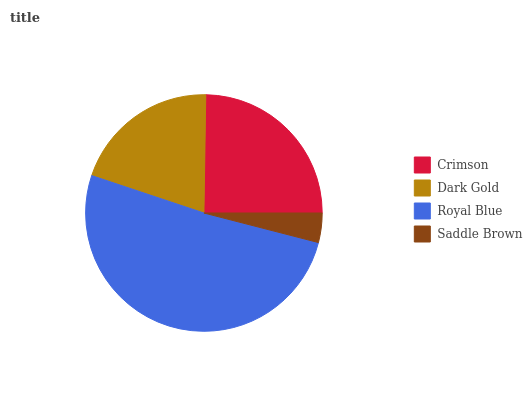Is Saddle Brown the minimum?
Answer yes or no. Yes. Is Royal Blue the maximum?
Answer yes or no. Yes. Is Dark Gold the minimum?
Answer yes or no. No. Is Dark Gold the maximum?
Answer yes or no. No. Is Crimson greater than Dark Gold?
Answer yes or no. Yes. Is Dark Gold less than Crimson?
Answer yes or no. Yes. Is Dark Gold greater than Crimson?
Answer yes or no. No. Is Crimson less than Dark Gold?
Answer yes or no. No. Is Crimson the high median?
Answer yes or no. Yes. Is Dark Gold the low median?
Answer yes or no. Yes. Is Dark Gold the high median?
Answer yes or no. No. Is Crimson the low median?
Answer yes or no. No. 